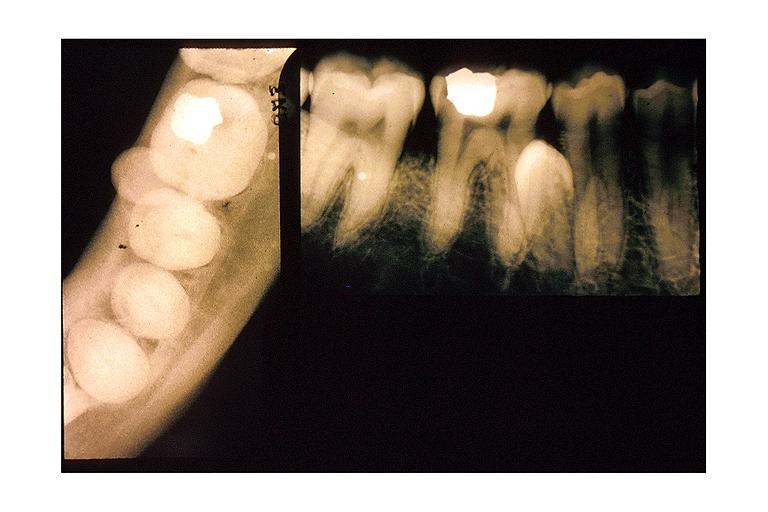s astrocytoma present?
Answer the question using a single word or phrase. No 